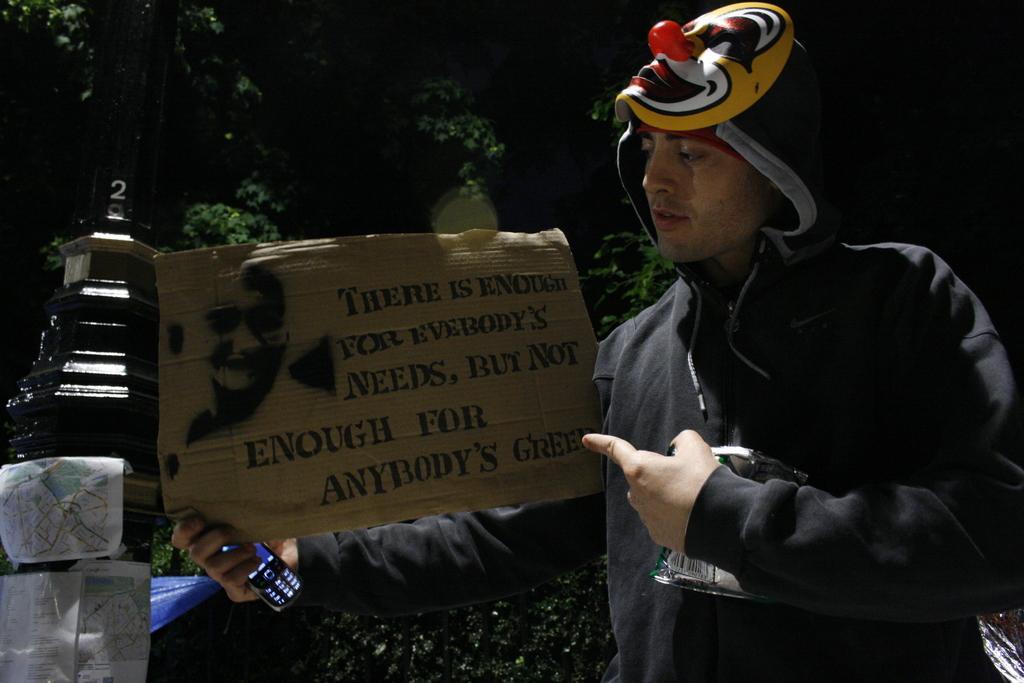Describe this image in one or two sentences. In this image there is a person wearing black color jacket holding a board and mobile phone in his right hand and at the left side of the image there is a pole and at the background there are trees. 